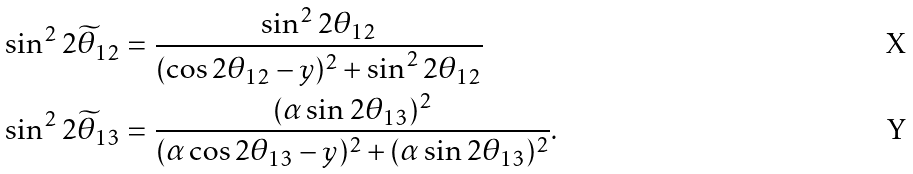Convert formula to latex. <formula><loc_0><loc_0><loc_500><loc_500>\sin ^ { 2 } 2 \widetilde { \theta } _ { 1 2 } & = \frac { \sin ^ { 2 } 2 \theta _ { 1 2 } } { ( \cos 2 \theta _ { 1 2 } - y ) ^ { 2 } + \sin ^ { 2 } 2 \theta _ { 1 2 } } \\ \sin ^ { 2 } 2 \widetilde { \theta } _ { 1 3 } & = \frac { ( \alpha \sin 2 \theta _ { 1 3 } ) ^ { 2 } } { ( \alpha \cos 2 \theta _ { 1 3 } - y ) ^ { 2 } + ( \alpha \sin 2 \theta _ { 1 3 } ) ^ { 2 } } .</formula> 